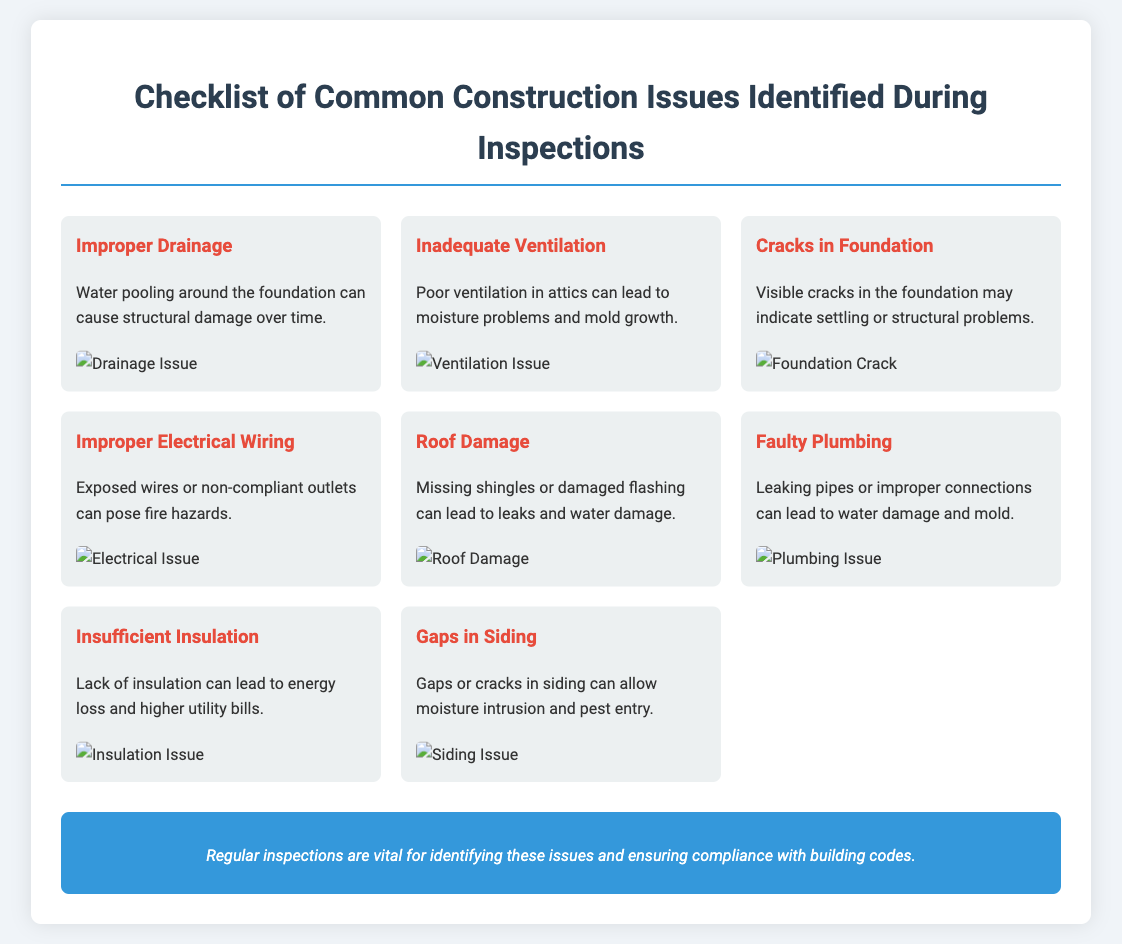What is the first issue listed in the checklist? The first issue listed is "Improper Drainage."
Answer: Improper Drainage How many issues are identified in the checklist? The document lists a total of 8 common construction issues.
Answer: 8 What is one consequence of inadequate ventilation? The document states that poor ventilation can lead to moisture problems and mold growth.
Answer: Mold growth What type of damage can missing shingles cause? The document mentions that missing shingles can lead to leaks and water damage.
Answer: Leaks and water damage Which issue is associated with exposed wires? The document indicates that exposed wires relate to "Improper Electrical Wiring," which poses fire hazards.
Answer: Improper Electrical Wiring What structural problem might visible cracks in the foundation indicate? The document suggests that visible cracks may indicate settling or structural problems.
Answer: Settling Which construction issue is linked to higher utility bills? The checklist states that "Insufficient Insulation" can lead to energy loss and higher utility bills.
Answer: Insufficient Insulation What is the color of the notes section in the document? The document describes the notes section as having a background color of blue.
Answer: Blue 